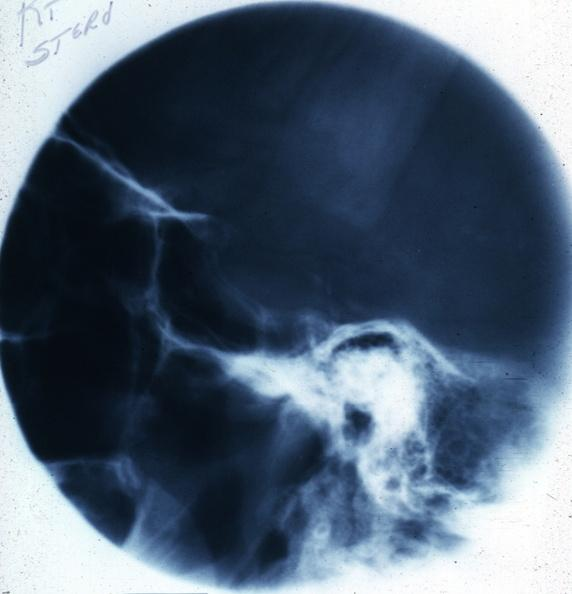s pituitary present?
Answer the question using a single word or phrase. Yes 